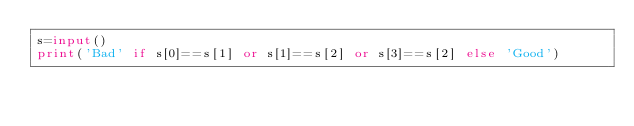<code> <loc_0><loc_0><loc_500><loc_500><_Python_>s=input()
print('Bad' if s[0]==s[1] or s[1]==s[2] or s[3]==s[2] else 'Good')</code> 